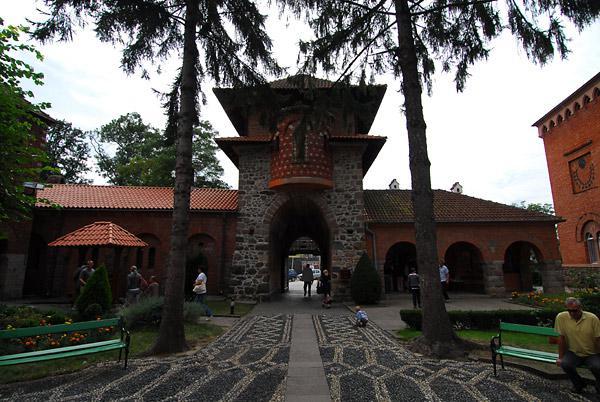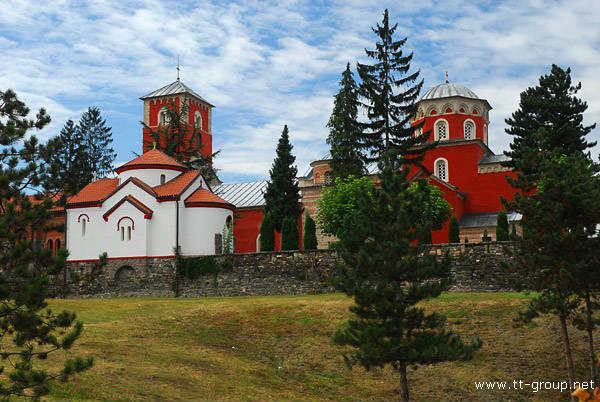The first image is the image on the left, the second image is the image on the right. Given the left and right images, does the statement "One of the images shows a long narrow paved path leading to an orange building with a cross atop." hold true? Answer yes or no. No. 